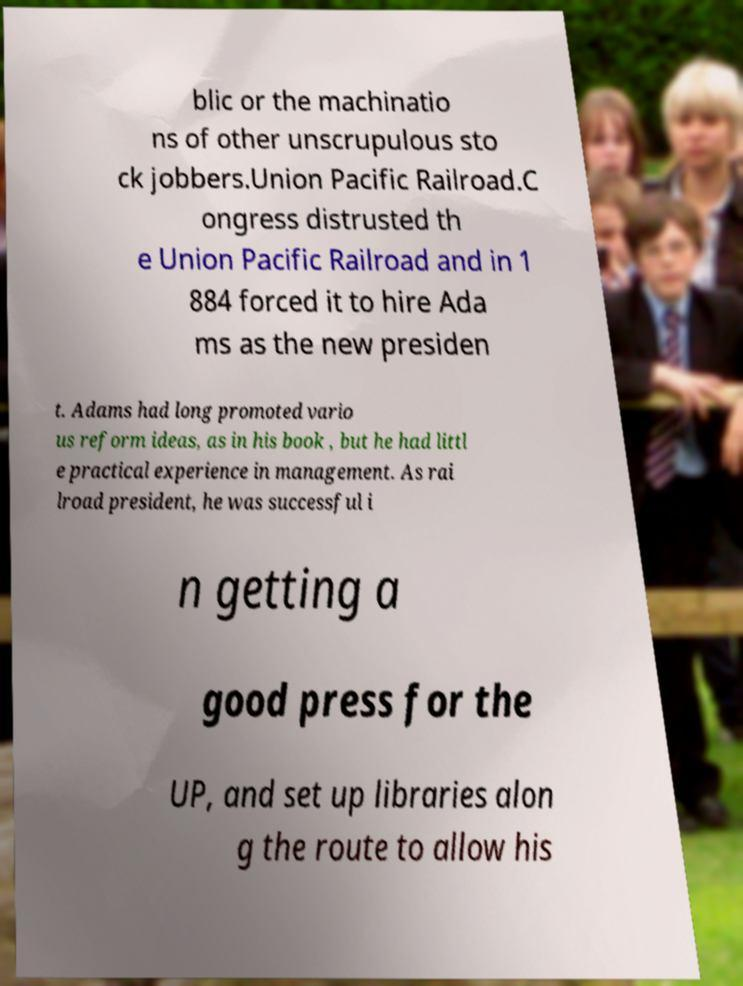Can you read and provide the text displayed in the image?This photo seems to have some interesting text. Can you extract and type it out for me? blic or the machinatio ns of other unscrupulous sto ck jobbers.Union Pacific Railroad.C ongress distrusted th e Union Pacific Railroad and in 1 884 forced it to hire Ada ms as the new presiden t. Adams had long promoted vario us reform ideas, as in his book , but he had littl e practical experience in management. As rai lroad president, he was successful i n getting a good press for the UP, and set up libraries alon g the route to allow his 